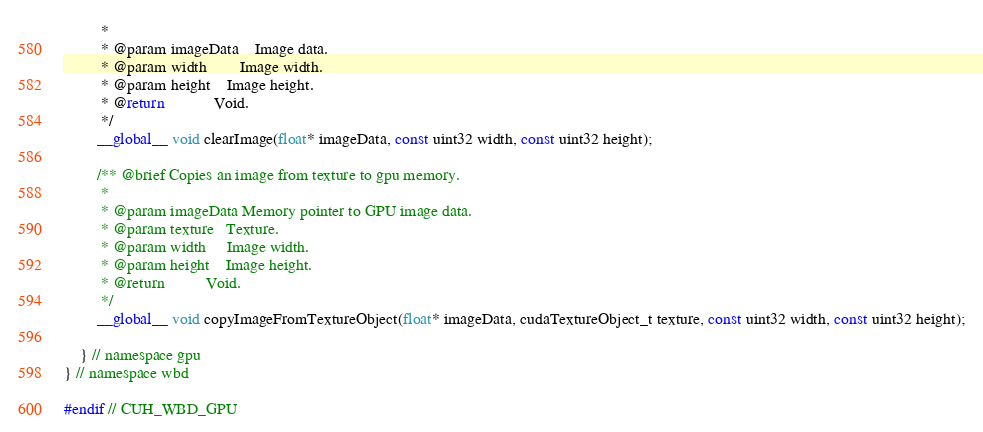<code> <loc_0><loc_0><loc_500><loc_500><_Cuda_>		 *
		 * @param imageData	Image data.
		 * @param width		Image width.
		 * @param height	Image height.
		 * @return			Void.
		 */
		__global__ void clearImage(float* imageData, const uint32 width, const uint32 height);

		/** @brief Copies an image from texture to gpu memory. 
		 *
		 * @param imageData	Memory pointer to GPU image data.
		 * @param texture	Texture.
		 * @param width		Image width.
		 * @param height	Image height.
		 * @return			Void.					
		 */
		__global__ void copyImageFromTextureObject(float* imageData, cudaTextureObject_t texture, const uint32 width, const uint32 height);

	} // namespace gpu
} // namespace wbd

#endif // CUH_WBD_GPU
</code> 